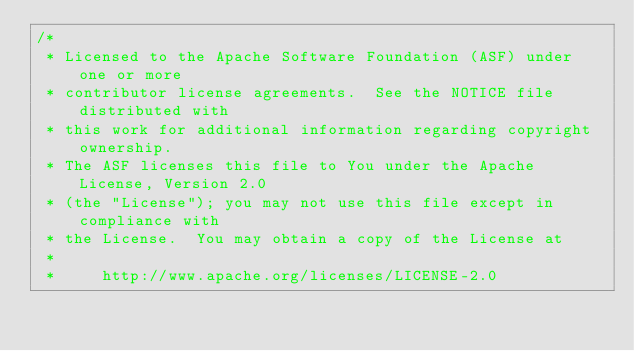<code> <loc_0><loc_0><loc_500><loc_500><_Java_>/*
 * Licensed to the Apache Software Foundation (ASF) under one or more
 * contributor license agreements.  See the NOTICE file distributed with
 * this work for additional information regarding copyright ownership.
 * The ASF licenses this file to You under the Apache License, Version 2.0
 * (the "License"); you may not use this file except in compliance with
 * the License.  You may obtain a copy of the License at
 *
 *     http://www.apache.org/licenses/LICENSE-2.0</code> 